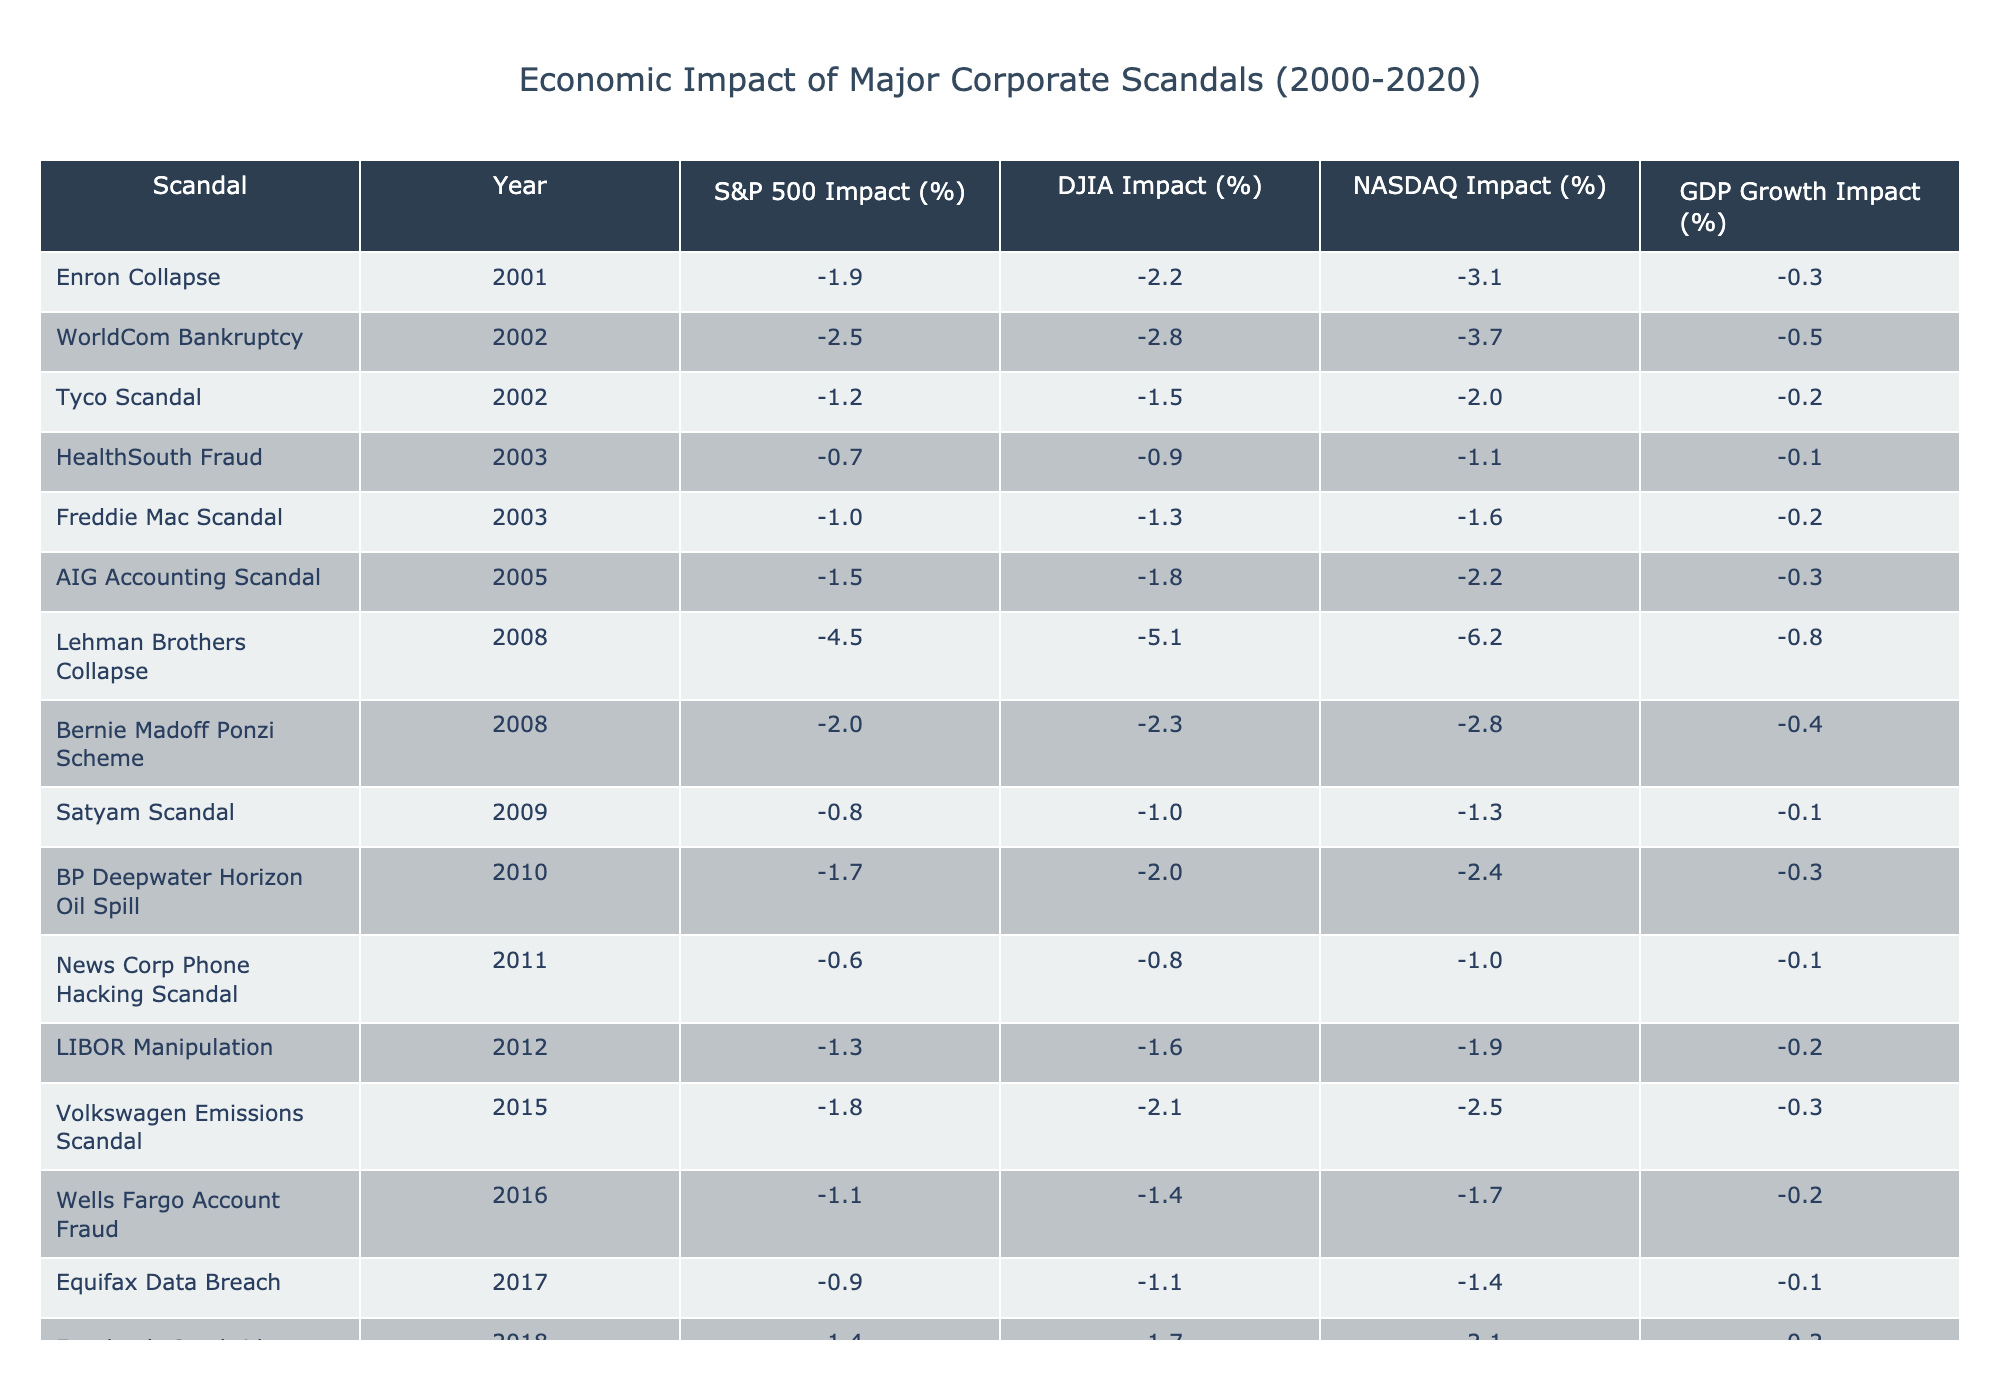What was the impact of the Lehman Brothers Collapse on the DJIA? The table shows that the DJIA impact of the Lehman Brothers Collapse in 2008 was -5.1%.
Answer: -5.1% Which scandal had the highest S&P 500 impact? The highest S&P 500 impact recorded in the table was from the Lehman Brothers Collapse in 2008, with an impact of -4.5%.
Answer: -4.5% Calculate the average GDP growth impact from corporate scandals for the years listed. By adding the GDP growth impact values (-0.3, -0.5, -0.2, -0.1, -0.2, -0.3, -0.8, -0.4, -0.3, -0.1, -0.2, -0.3, -0.2, -0.1, -0.4, -0.3) we get -0.3, and since there are 16 scandals listed, we divide by 16: -0.3 / 16 = -0.01875. This rounds the average GDP growth impact to approximately -0.02.
Answer: -0.02 Did the Tyco Scandal have a greater impact on the NASDAQ than the HealthSouth Fraud? The NASDAQ impact from the Tyco Scandal in 2002 was -2.0%, while the HealthSouth Fraud in 2003 had a NASDAQ impact of -1.1%. Therefore, the Tyco Scandal had a greater impact on the NASDAQ than the HealthSouth Fraud.
Answer: Yes Which corporate scandal had the least impact on the GDP growth? According to the table, the scandals with the least GDP growth impact were HealthSouth Fraud and Satyam Scandal, both having an impact of -0.1%.
Answer: -0.1% What is the total negative impact on the S&P 500 from scandal events in 2008? The S&P 500 impacts for scandals in 2008 are -4.5% from Lehman Brothers and -2.0% from Bernie Madoff, summing these gives: -4.5 + -2.0 = -6.5%.
Answer: -6.5% Compare the impact on the DJIA from the Enron Collapse and the WorldCom Bankruptcy. The DJIA impact of the Enron Collapse in 2001 was -2.2%, while the WorldCom Bankruptcy in 2002 had a DJIA impact of -2.8%. Therefore, the WorldCom Bankruptcy had a larger negative impact.
Answer: WorldCom Bankruptcy had a larger impact What was the change in NASDAQ impact from the Bernie Madoff Ponzi Scheme to the Lehman Brothers Collapse? The NASDAQ impact from the Bernie Madoff Ponzi Scheme in 2008 was -2.8%, while the impact from the Lehman Brothers Collapse was -6.2%. The change in impact is: -6.2 - (-2.8) = -3.4%, indicating a significant worsening.
Answer: -3.4% Which scandal had the smallest impact on the DJIA over the entire period? Reviewing the DJIA impact values, the scandal with the smallest DJIA impact was the News Corp Phone Hacking Scandal in 2011, with an impact of -0.8%.
Answer: -0.8% Was there a trend of increasing negative impacts on the stock indices from corporate scandals over the years? Analyzing the table trends: the impacts on S&P 500, DJIA, and NASDAQ are generally more negative in the later years (especially noticeable with Lehman Brothers and Bernie Madoff). This suggests a trend towards increasing negative impacts from the scandals.
Answer: Yes 